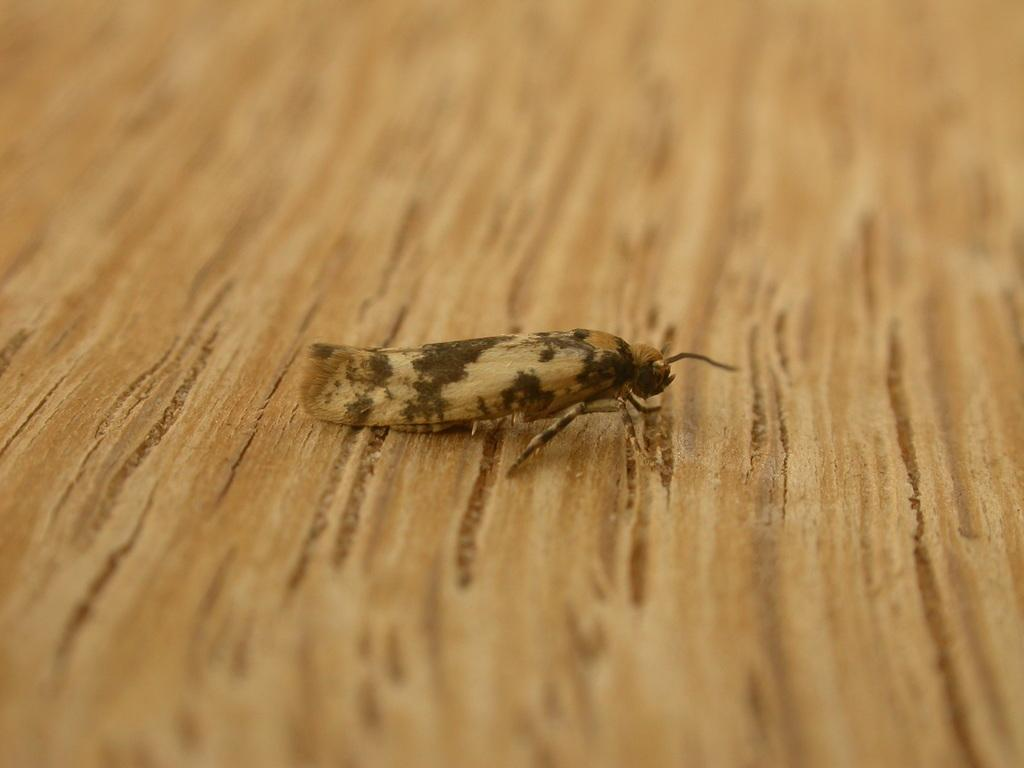What is present on the wooden table in the image? There is an insect on the wooden table in the image. Can you describe the background of the image? The background of the image is blurred. What type of string is being used in the picture? There is no string present in the image. What operation is being performed on the insect in the image? There is no operation being performed on the insect in the image; it is simply sitting on the wooden table. 